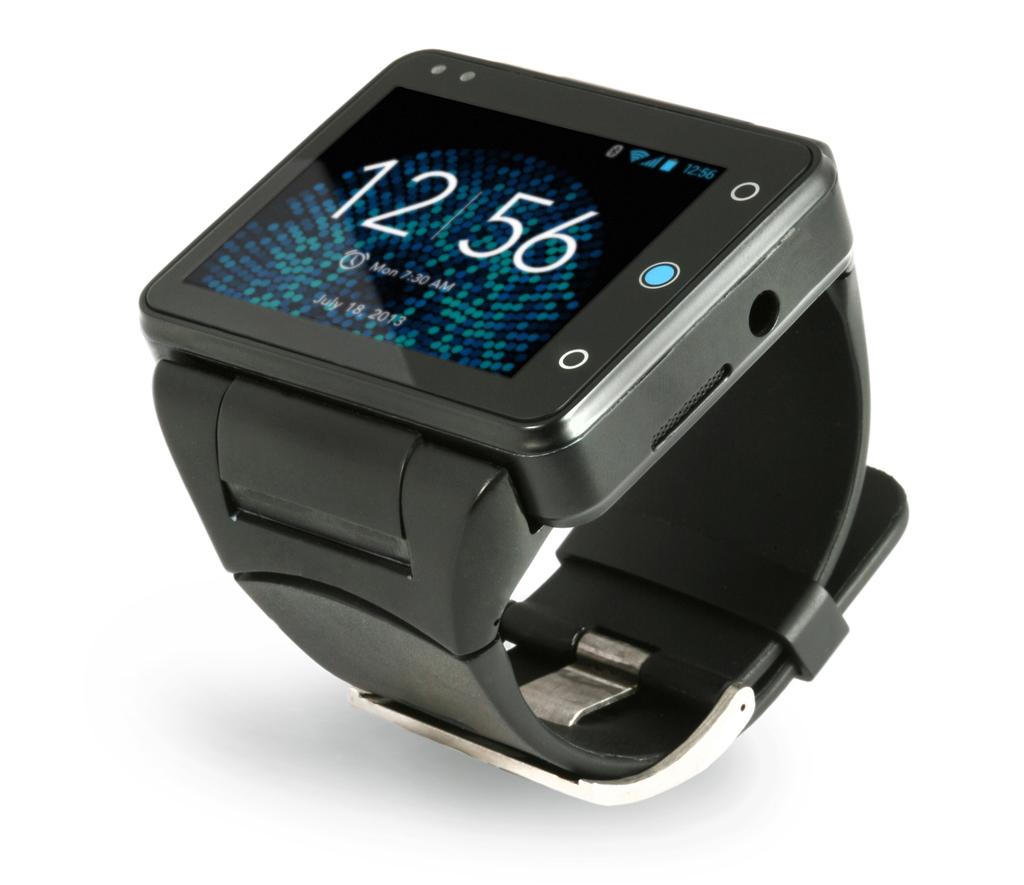What hour does the black sport watch show?
Keep it short and to the point. 12:56. What day does the screen say it is?
Your answer should be very brief. Monday. 